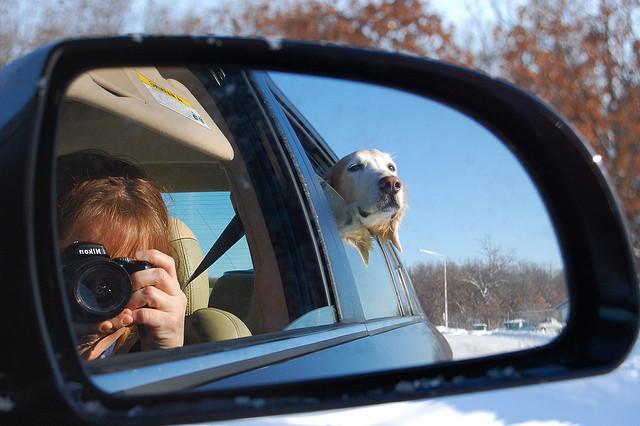Which lens used in side mirror of the car? camera 